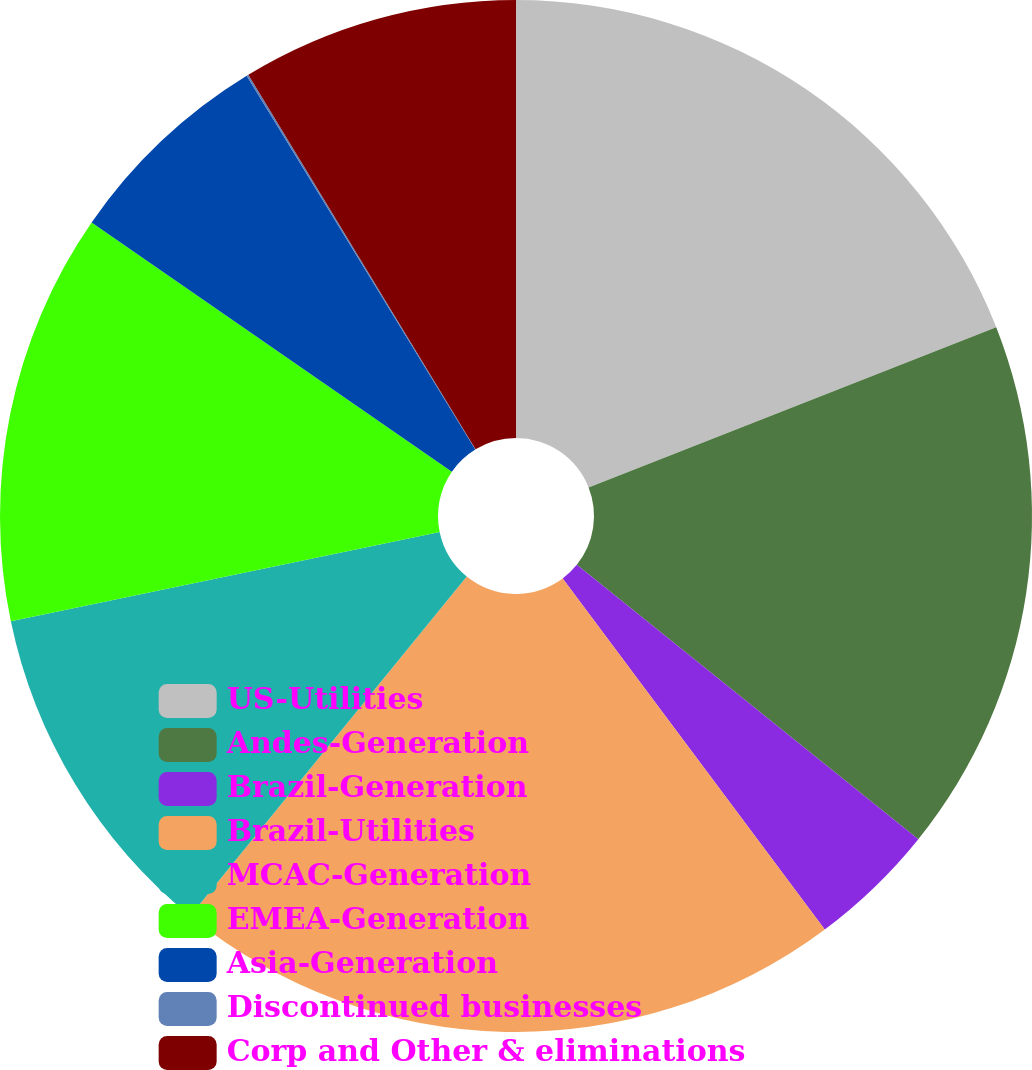Convert chart. <chart><loc_0><loc_0><loc_500><loc_500><pie_chart><fcel>US-Utilities<fcel>Andes-Generation<fcel>Brazil-Generation<fcel>Brazil-Utilities<fcel>MCAC-Generation<fcel>EMEA-Generation<fcel>Asia-Generation<fcel>Discontinued businesses<fcel>Corp and Other & eliminations<nl><fcel>19.04%<fcel>16.73%<fcel>4.02%<fcel>21.09%<fcel>10.85%<fcel>12.9%<fcel>6.63%<fcel>0.06%<fcel>8.68%<nl></chart> 